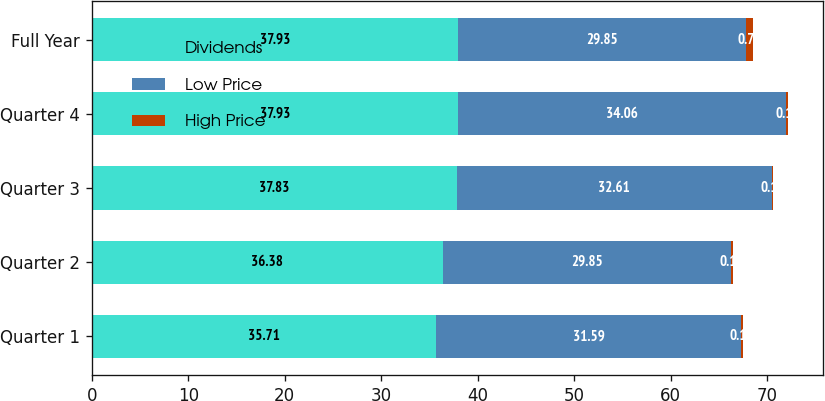Convert chart. <chart><loc_0><loc_0><loc_500><loc_500><stacked_bar_chart><ecel><fcel>Quarter 1<fcel>Quarter 2<fcel>Quarter 3<fcel>Quarter 4<fcel>Full Year<nl><fcel>Dividends<fcel>35.71<fcel>36.38<fcel>37.83<fcel>37.93<fcel>37.93<nl><fcel>Low Price<fcel>31.59<fcel>29.85<fcel>32.61<fcel>34.06<fcel>29.85<nl><fcel>High Price<fcel>0.17<fcel>0.17<fcel>0.19<fcel>0.19<fcel>0.72<nl></chart> 